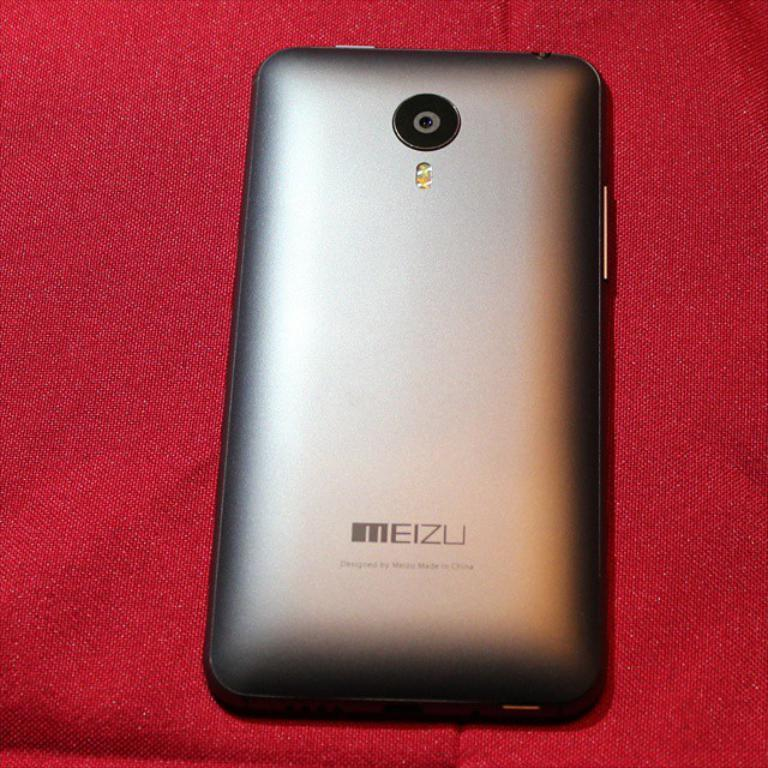<image>
Provide a brief description of the given image. A Meizu device is face down on a red cloth. 